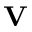<formula> <loc_0><loc_0><loc_500><loc_500>V</formula> 